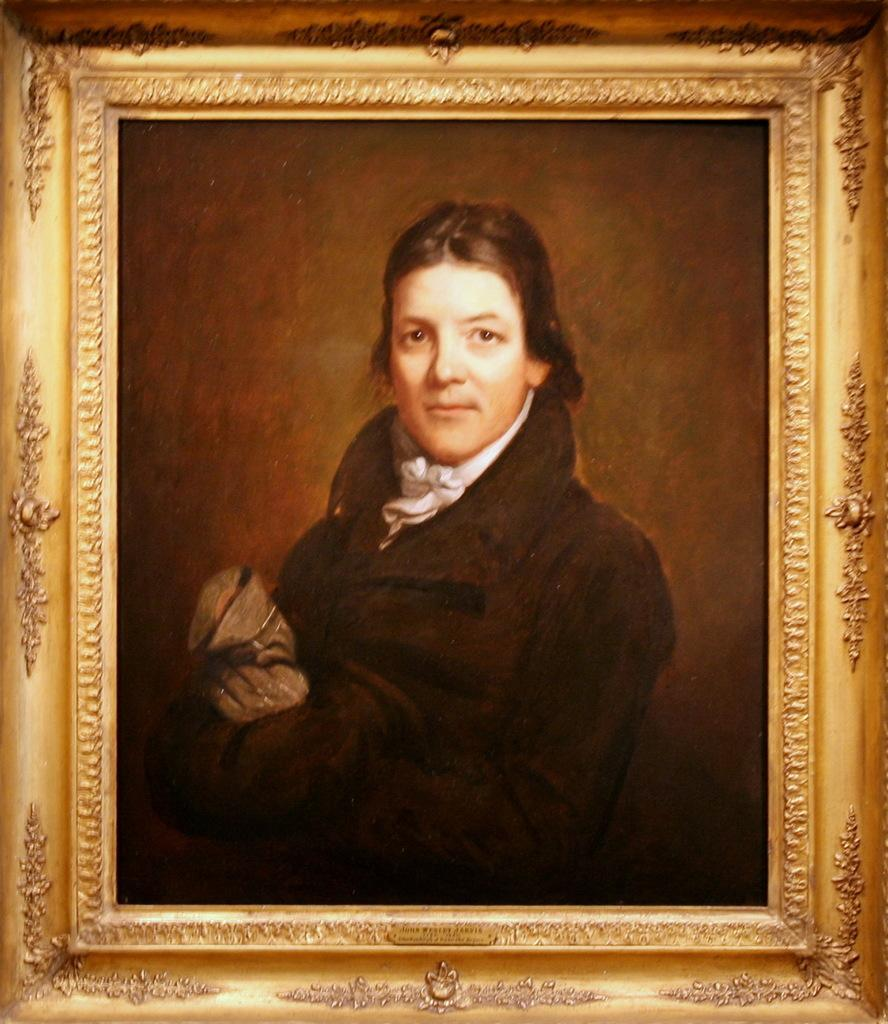What is the main subject of the image? There is a person depicted in a photo frame in the image. What type of plant is growing in the photo frame? There is no plant growing in the photo frame; the image only depicts a person. 